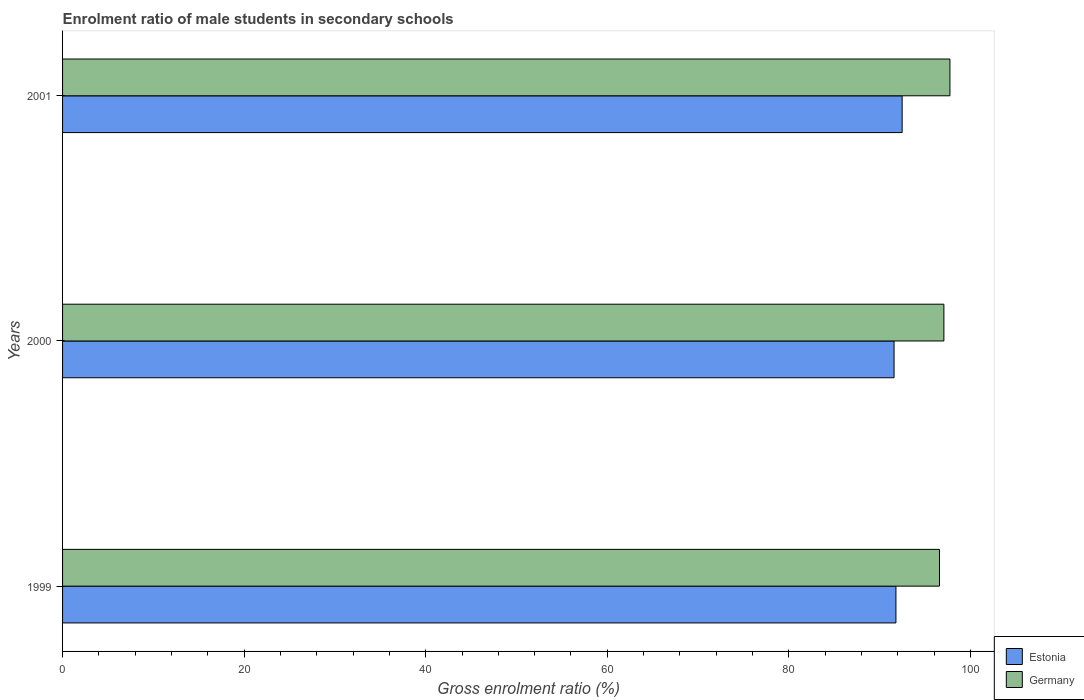Are the number of bars per tick equal to the number of legend labels?
Your answer should be compact. Yes. What is the enrolment ratio of male students in secondary schools in Germany in 1999?
Your answer should be very brief. 96.6. Across all years, what is the maximum enrolment ratio of male students in secondary schools in Germany?
Keep it short and to the point. 97.75. Across all years, what is the minimum enrolment ratio of male students in secondary schools in Estonia?
Provide a succinct answer. 91.6. In which year was the enrolment ratio of male students in secondary schools in Germany maximum?
Your response must be concise. 2001. What is the total enrolment ratio of male students in secondary schools in Estonia in the graph?
Ensure brevity in your answer.  275.88. What is the difference between the enrolment ratio of male students in secondary schools in Estonia in 1999 and that in 2000?
Offer a terse response. 0.21. What is the difference between the enrolment ratio of male students in secondary schools in Germany in 2000 and the enrolment ratio of male students in secondary schools in Estonia in 1999?
Your answer should be compact. 5.28. What is the average enrolment ratio of male students in secondary schools in Estonia per year?
Make the answer very short. 91.96. In the year 1999, what is the difference between the enrolment ratio of male students in secondary schools in Estonia and enrolment ratio of male students in secondary schools in Germany?
Your answer should be compact. -4.8. What is the ratio of the enrolment ratio of male students in secondary schools in Estonia in 1999 to that in 2001?
Offer a terse response. 0.99. Is the difference between the enrolment ratio of male students in secondary schools in Estonia in 2000 and 2001 greater than the difference between the enrolment ratio of male students in secondary schools in Germany in 2000 and 2001?
Your answer should be very brief. No. What is the difference between the highest and the second highest enrolment ratio of male students in secondary schools in Germany?
Your response must be concise. 0.67. What is the difference between the highest and the lowest enrolment ratio of male students in secondary schools in Germany?
Provide a succinct answer. 1.15. In how many years, is the enrolment ratio of male students in secondary schools in Estonia greater than the average enrolment ratio of male students in secondary schools in Estonia taken over all years?
Make the answer very short. 1. Is the sum of the enrolment ratio of male students in secondary schools in Germany in 1999 and 2000 greater than the maximum enrolment ratio of male students in secondary schools in Estonia across all years?
Ensure brevity in your answer.  Yes. What does the 1st bar from the top in 1999 represents?
Give a very brief answer. Germany. What does the 2nd bar from the bottom in 1999 represents?
Give a very brief answer. Germany. How many bars are there?
Give a very brief answer. 6. Are all the bars in the graph horizontal?
Ensure brevity in your answer.  Yes. How many years are there in the graph?
Keep it short and to the point. 3. Are the values on the major ticks of X-axis written in scientific E-notation?
Ensure brevity in your answer.  No. Where does the legend appear in the graph?
Ensure brevity in your answer.  Bottom right. How are the legend labels stacked?
Give a very brief answer. Vertical. What is the title of the graph?
Your response must be concise. Enrolment ratio of male students in secondary schools. What is the label or title of the X-axis?
Keep it short and to the point. Gross enrolment ratio (%). What is the label or title of the Y-axis?
Make the answer very short. Years. What is the Gross enrolment ratio (%) in Estonia in 1999?
Provide a succinct answer. 91.8. What is the Gross enrolment ratio (%) of Germany in 1999?
Provide a succinct answer. 96.6. What is the Gross enrolment ratio (%) of Estonia in 2000?
Provide a succinct answer. 91.6. What is the Gross enrolment ratio (%) of Germany in 2000?
Your response must be concise. 97.08. What is the Gross enrolment ratio (%) of Estonia in 2001?
Provide a succinct answer. 92.48. What is the Gross enrolment ratio (%) in Germany in 2001?
Your response must be concise. 97.75. Across all years, what is the maximum Gross enrolment ratio (%) in Estonia?
Offer a very short reply. 92.48. Across all years, what is the maximum Gross enrolment ratio (%) in Germany?
Keep it short and to the point. 97.75. Across all years, what is the minimum Gross enrolment ratio (%) of Estonia?
Keep it short and to the point. 91.6. Across all years, what is the minimum Gross enrolment ratio (%) of Germany?
Keep it short and to the point. 96.6. What is the total Gross enrolment ratio (%) in Estonia in the graph?
Your response must be concise. 275.88. What is the total Gross enrolment ratio (%) of Germany in the graph?
Give a very brief answer. 291.43. What is the difference between the Gross enrolment ratio (%) of Estonia in 1999 and that in 2000?
Ensure brevity in your answer.  0.21. What is the difference between the Gross enrolment ratio (%) in Germany in 1999 and that in 2000?
Provide a short and direct response. -0.49. What is the difference between the Gross enrolment ratio (%) of Estonia in 1999 and that in 2001?
Ensure brevity in your answer.  -0.68. What is the difference between the Gross enrolment ratio (%) in Germany in 1999 and that in 2001?
Your answer should be very brief. -1.15. What is the difference between the Gross enrolment ratio (%) in Estonia in 2000 and that in 2001?
Provide a short and direct response. -0.89. What is the difference between the Gross enrolment ratio (%) in Germany in 2000 and that in 2001?
Your answer should be very brief. -0.67. What is the difference between the Gross enrolment ratio (%) in Estonia in 1999 and the Gross enrolment ratio (%) in Germany in 2000?
Ensure brevity in your answer.  -5.28. What is the difference between the Gross enrolment ratio (%) in Estonia in 1999 and the Gross enrolment ratio (%) in Germany in 2001?
Give a very brief answer. -5.95. What is the difference between the Gross enrolment ratio (%) in Estonia in 2000 and the Gross enrolment ratio (%) in Germany in 2001?
Provide a short and direct response. -6.15. What is the average Gross enrolment ratio (%) in Estonia per year?
Make the answer very short. 91.96. What is the average Gross enrolment ratio (%) in Germany per year?
Your response must be concise. 97.14. In the year 1999, what is the difference between the Gross enrolment ratio (%) of Estonia and Gross enrolment ratio (%) of Germany?
Provide a succinct answer. -4.8. In the year 2000, what is the difference between the Gross enrolment ratio (%) of Estonia and Gross enrolment ratio (%) of Germany?
Offer a very short reply. -5.49. In the year 2001, what is the difference between the Gross enrolment ratio (%) of Estonia and Gross enrolment ratio (%) of Germany?
Keep it short and to the point. -5.27. What is the ratio of the Gross enrolment ratio (%) in Estonia in 1999 to that in 2000?
Make the answer very short. 1. What is the ratio of the Gross enrolment ratio (%) in Estonia in 1999 to that in 2001?
Make the answer very short. 0.99. What is the ratio of the Gross enrolment ratio (%) in Germany in 1999 to that in 2001?
Ensure brevity in your answer.  0.99. What is the difference between the highest and the second highest Gross enrolment ratio (%) in Estonia?
Provide a succinct answer. 0.68. What is the difference between the highest and the second highest Gross enrolment ratio (%) in Germany?
Ensure brevity in your answer.  0.67. What is the difference between the highest and the lowest Gross enrolment ratio (%) in Estonia?
Give a very brief answer. 0.89. What is the difference between the highest and the lowest Gross enrolment ratio (%) in Germany?
Your answer should be very brief. 1.15. 